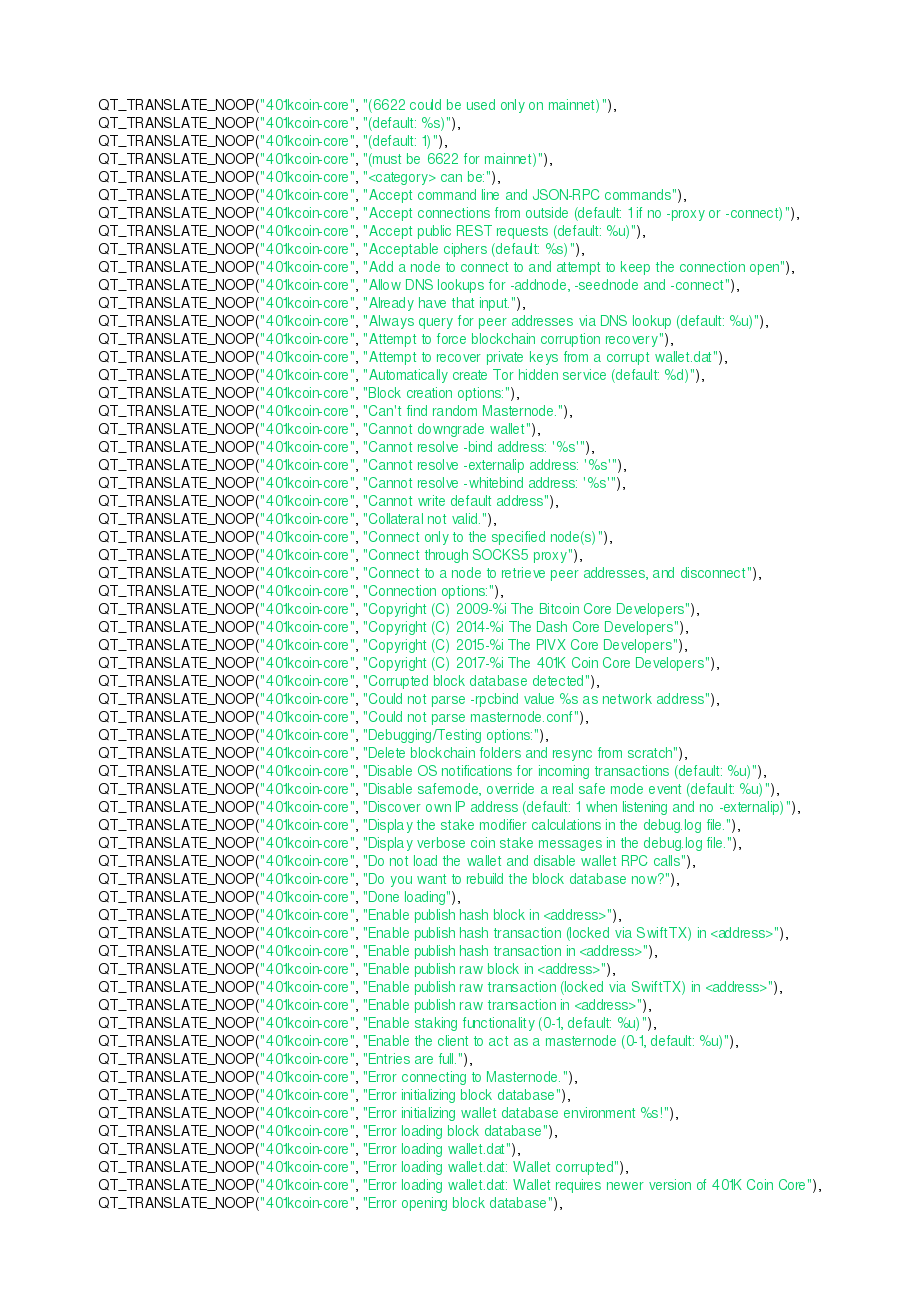Convert code to text. <code><loc_0><loc_0><loc_500><loc_500><_C++_>QT_TRANSLATE_NOOP("401kcoin-core", "(6622 could be used only on mainnet)"),
QT_TRANSLATE_NOOP("401kcoin-core", "(default: %s)"),
QT_TRANSLATE_NOOP("401kcoin-core", "(default: 1)"),
QT_TRANSLATE_NOOP("401kcoin-core", "(must be 6622 for mainnet)"),
QT_TRANSLATE_NOOP("401kcoin-core", "<category> can be:"),
QT_TRANSLATE_NOOP("401kcoin-core", "Accept command line and JSON-RPC commands"),
QT_TRANSLATE_NOOP("401kcoin-core", "Accept connections from outside (default: 1 if no -proxy or -connect)"),
QT_TRANSLATE_NOOP("401kcoin-core", "Accept public REST requests (default: %u)"),
QT_TRANSLATE_NOOP("401kcoin-core", "Acceptable ciphers (default: %s)"),
QT_TRANSLATE_NOOP("401kcoin-core", "Add a node to connect to and attempt to keep the connection open"),
QT_TRANSLATE_NOOP("401kcoin-core", "Allow DNS lookups for -addnode, -seednode and -connect"),
QT_TRANSLATE_NOOP("401kcoin-core", "Already have that input."),
QT_TRANSLATE_NOOP("401kcoin-core", "Always query for peer addresses via DNS lookup (default: %u)"),
QT_TRANSLATE_NOOP("401kcoin-core", "Attempt to force blockchain corruption recovery"),
QT_TRANSLATE_NOOP("401kcoin-core", "Attempt to recover private keys from a corrupt wallet.dat"),
QT_TRANSLATE_NOOP("401kcoin-core", "Automatically create Tor hidden service (default: %d)"),
QT_TRANSLATE_NOOP("401kcoin-core", "Block creation options:"),
QT_TRANSLATE_NOOP("401kcoin-core", "Can't find random Masternode."),
QT_TRANSLATE_NOOP("401kcoin-core", "Cannot downgrade wallet"),
QT_TRANSLATE_NOOP("401kcoin-core", "Cannot resolve -bind address: '%s'"),
QT_TRANSLATE_NOOP("401kcoin-core", "Cannot resolve -externalip address: '%s'"),
QT_TRANSLATE_NOOP("401kcoin-core", "Cannot resolve -whitebind address: '%s'"),
QT_TRANSLATE_NOOP("401kcoin-core", "Cannot write default address"),
QT_TRANSLATE_NOOP("401kcoin-core", "Collateral not valid."),
QT_TRANSLATE_NOOP("401kcoin-core", "Connect only to the specified node(s)"),
QT_TRANSLATE_NOOP("401kcoin-core", "Connect through SOCKS5 proxy"),
QT_TRANSLATE_NOOP("401kcoin-core", "Connect to a node to retrieve peer addresses, and disconnect"),
QT_TRANSLATE_NOOP("401kcoin-core", "Connection options:"),
QT_TRANSLATE_NOOP("401kcoin-core", "Copyright (C) 2009-%i The Bitcoin Core Developers"),
QT_TRANSLATE_NOOP("401kcoin-core", "Copyright (C) 2014-%i The Dash Core Developers"),
QT_TRANSLATE_NOOP("401kcoin-core", "Copyright (C) 2015-%i The PIVX Core Developers"),
QT_TRANSLATE_NOOP("401kcoin-core", "Copyright (C) 2017-%i The 401K Coin Core Developers"),
QT_TRANSLATE_NOOP("401kcoin-core", "Corrupted block database detected"),
QT_TRANSLATE_NOOP("401kcoin-core", "Could not parse -rpcbind value %s as network address"),
QT_TRANSLATE_NOOP("401kcoin-core", "Could not parse masternode.conf"),
QT_TRANSLATE_NOOP("401kcoin-core", "Debugging/Testing options:"),
QT_TRANSLATE_NOOP("401kcoin-core", "Delete blockchain folders and resync from scratch"),
QT_TRANSLATE_NOOP("401kcoin-core", "Disable OS notifications for incoming transactions (default: %u)"),
QT_TRANSLATE_NOOP("401kcoin-core", "Disable safemode, override a real safe mode event (default: %u)"),
QT_TRANSLATE_NOOP("401kcoin-core", "Discover own IP address (default: 1 when listening and no -externalip)"),
QT_TRANSLATE_NOOP("401kcoin-core", "Display the stake modifier calculations in the debug.log file."),
QT_TRANSLATE_NOOP("401kcoin-core", "Display verbose coin stake messages in the debug.log file."),
QT_TRANSLATE_NOOP("401kcoin-core", "Do not load the wallet and disable wallet RPC calls"),
QT_TRANSLATE_NOOP("401kcoin-core", "Do you want to rebuild the block database now?"),
QT_TRANSLATE_NOOP("401kcoin-core", "Done loading"),
QT_TRANSLATE_NOOP("401kcoin-core", "Enable publish hash block in <address>"),
QT_TRANSLATE_NOOP("401kcoin-core", "Enable publish hash transaction (locked via SwiftTX) in <address>"),
QT_TRANSLATE_NOOP("401kcoin-core", "Enable publish hash transaction in <address>"),
QT_TRANSLATE_NOOP("401kcoin-core", "Enable publish raw block in <address>"),
QT_TRANSLATE_NOOP("401kcoin-core", "Enable publish raw transaction (locked via SwiftTX) in <address>"),
QT_TRANSLATE_NOOP("401kcoin-core", "Enable publish raw transaction in <address>"),
QT_TRANSLATE_NOOP("401kcoin-core", "Enable staking functionality (0-1, default: %u)"),
QT_TRANSLATE_NOOP("401kcoin-core", "Enable the client to act as a masternode (0-1, default: %u)"),
QT_TRANSLATE_NOOP("401kcoin-core", "Entries are full."),
QT_TRANSLATE_NOOP("401kcoin-core", "Error connecting to Masternode."),
QT_TRANSLATE_NOOP("401kcoin-core", "Error initializing block database"),
QT_TRANSLATE_NOOP("401kcoin-core", "Error initializing wallet database environment %s!"),
QT_TRANSLATE_NOOP("401kcoin-core", "Error loading block database"),
QT_TRANSLATE_NOOP("401kcoin-core", "Error loading wallet.dat"),
QT_TRANSLATE_NOOP("401kcoin-core", "Error loading wallet.dat: Wallet corrupted"),
QT_TRANSLATE_NOOP("401kcoin-core", "Error loading wallet.dat: Wallet requires newer version of 401K Coin Core"),
QT_TRANSLATE_NOOP("401kcoin-core", "Error opening block database"),</code> 